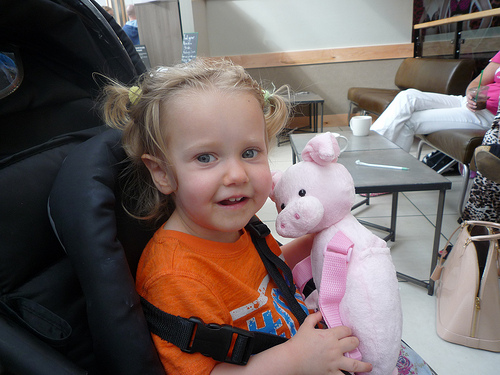<image>
Is the pig on the child? Yes. Looking at the image, I can see the pig is positioned on top of the child, with the child providing support. 